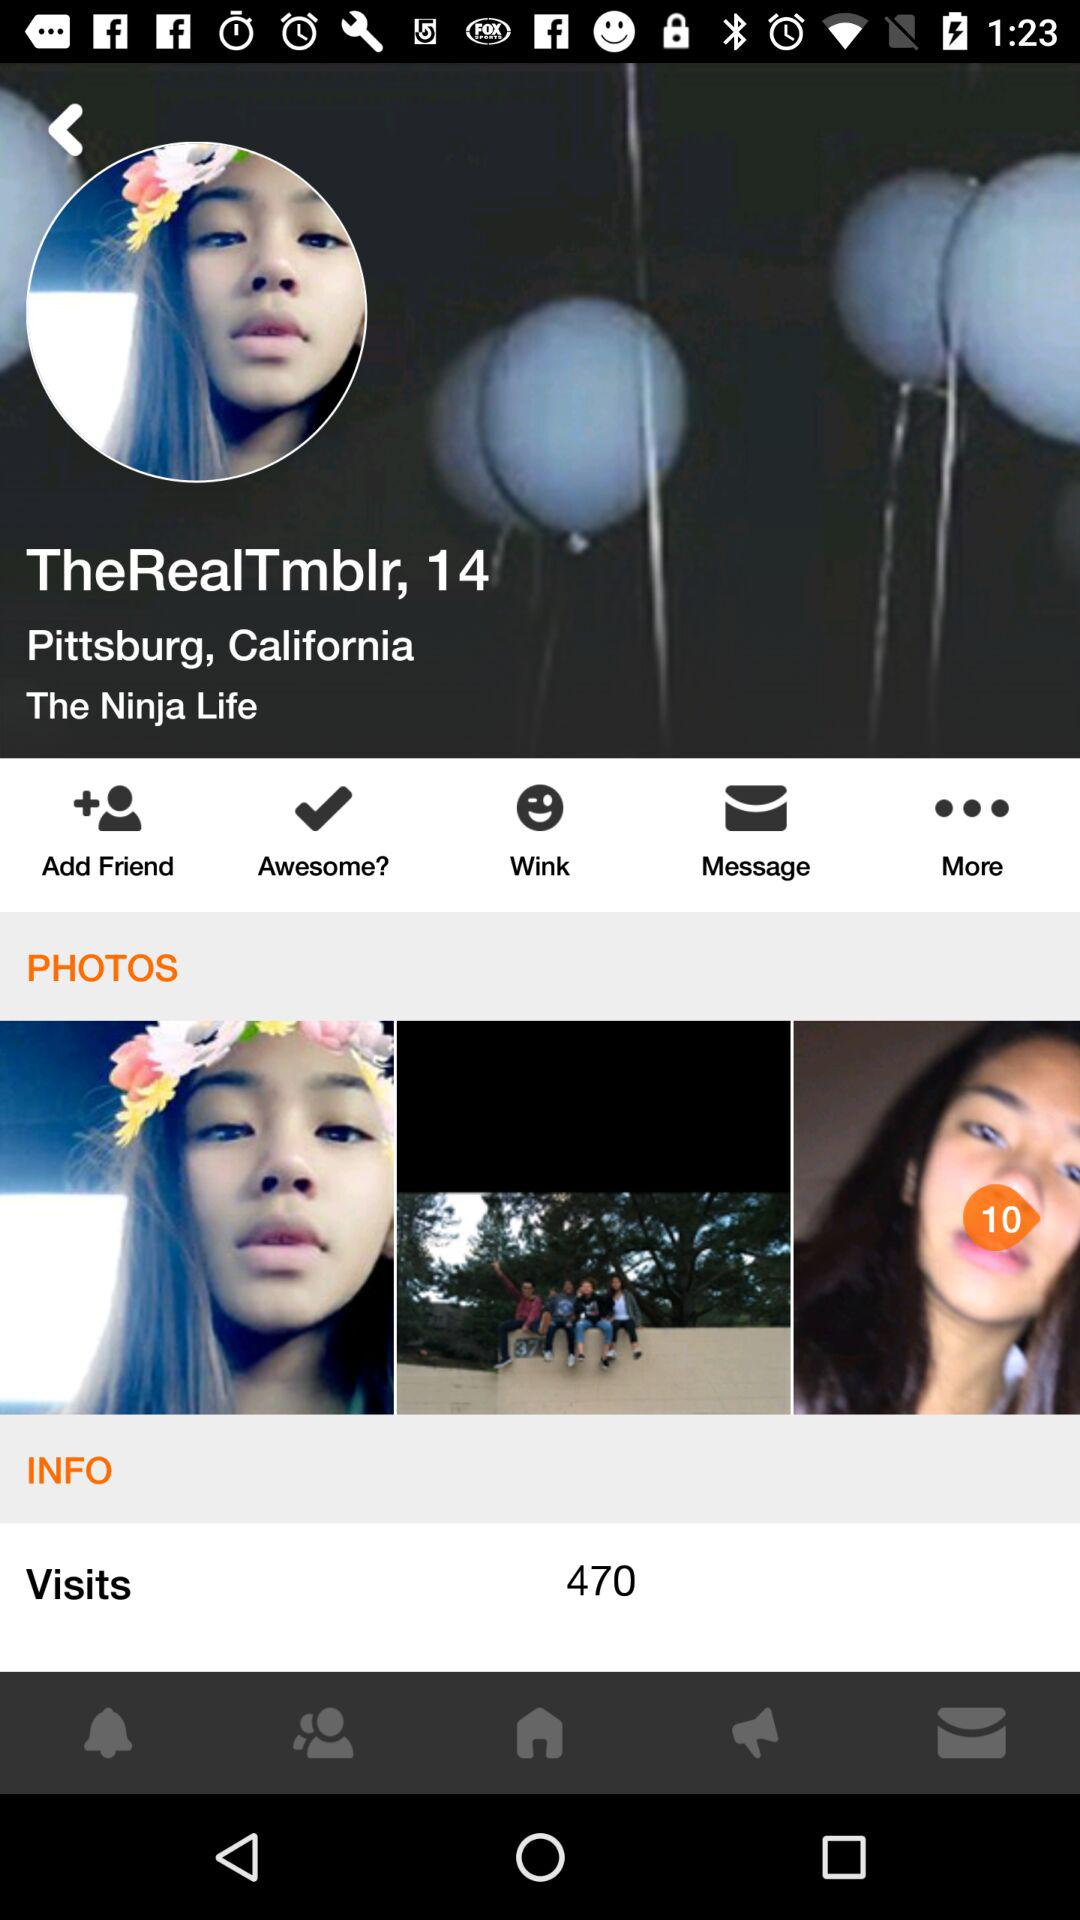What is the location? The location is Pittsburg, California. 